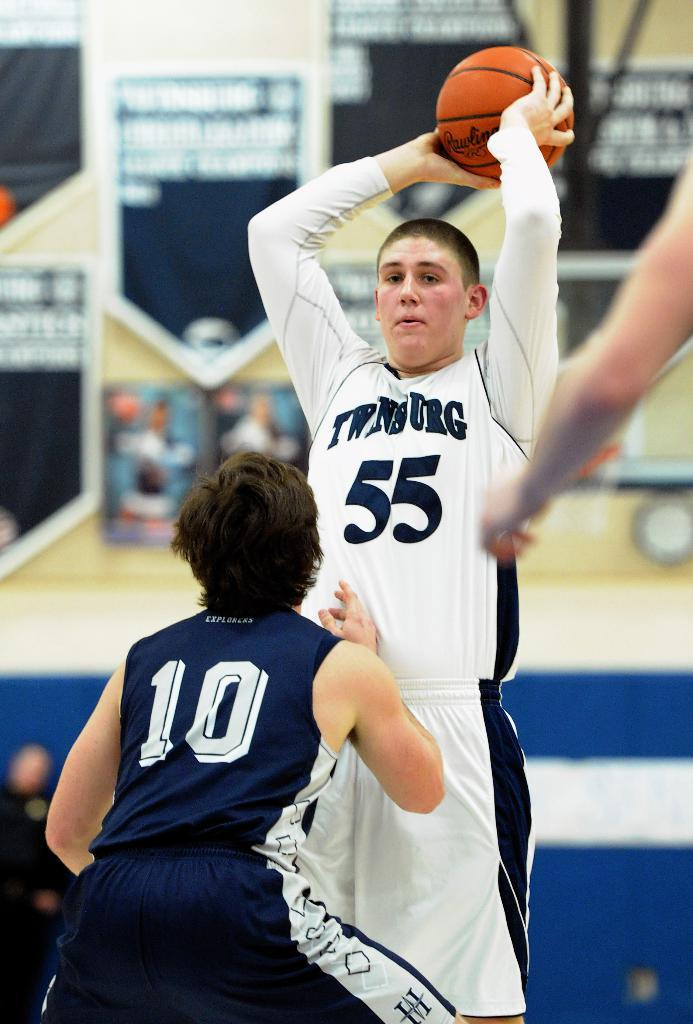<image>
Describe the image concisely. Two men playing basketball, one of whom has a number ten on a blue shirt. 